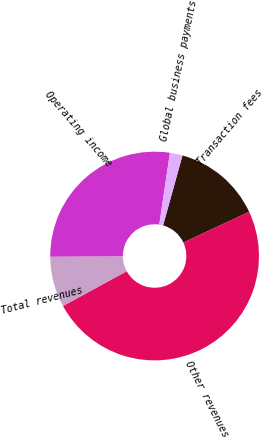<chart> <loc_0><loc_0><loc_500><loc_500><pie_chart><fcel>Transaction fees<fcel>Other revenues<fcel>Total revenues<fcel>Operating income<fcel>Global business payments<nl><fcel>13.73%<fcel>49.02%<fcel>7.84%<fcel>27.45%<fcel>1.96%<nl></chart> 